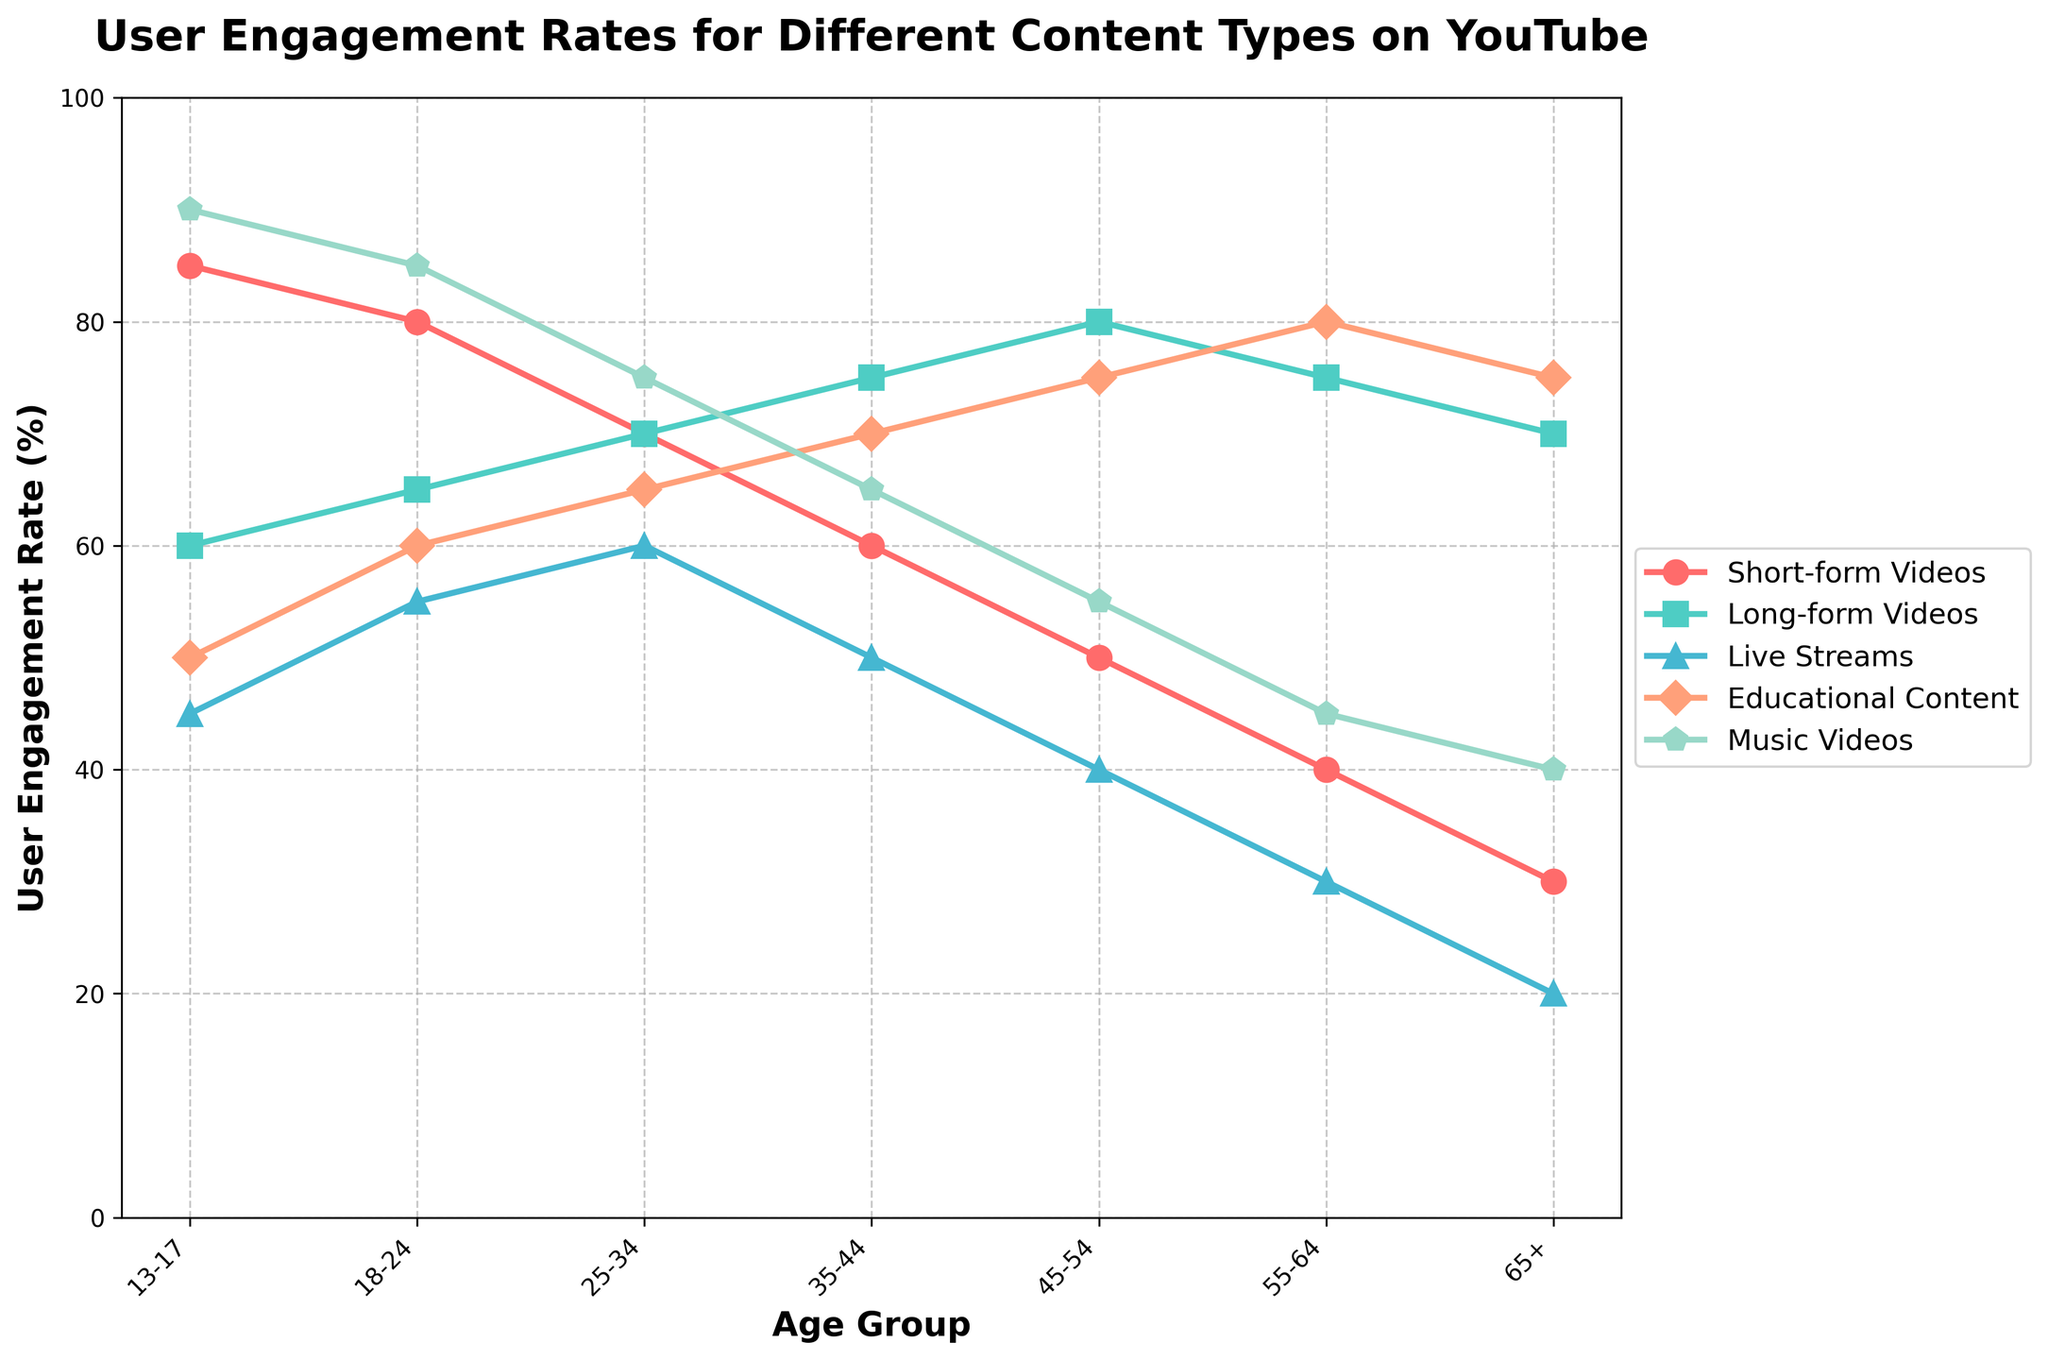Which age group has the highest engagement rate for short-form videos? Looking at the plot, the highest line for short-form videos is at the leftmost part of the chart. The age group 13-17 shows the highest point in the short-form videos line.
Answer: 13-17 Which content type shows a consistent increase in engagement rate as the age group increases from 13-17 to 55-64? Reviewing all the lines, Educational Content shows a consistent increase from age group 13-17 to age group 55-64.
Answer: Educational Content What's the difference in engagement rates between music videos and live streams for the 25-34 age group? Finding the respective points for the 25-34 age group, music videos are at 75, and live streams are at 60. The difference is 75 - 60.
Answer: 15 Among all the content types, which has the lowest engagement rate for the 65+ age group? Finding the points corresponding to the 65+ age group on the plot for each content type, Live Streams shows the lowest engagement rate at 20.
Answer: Live Streams What is the average engagement rate for long-form videos across all age groups? Identifying the values for long-form videos (60, 65, 70, 75, 80, 75, 70) and calculating their average: (60 + 65 + 70 + 75 + 80 + 75 + 70) / 7 = 70.71
Answer: 70.71 How does the engagement rate for short-form videos compare to educational content for the 18-24 age group? Checking the values for the 18-24 age group, short-form videos have an engagement rate of 80, and educational content has a rate of 60. Short-form videos have a higher engagement rate.
Answer: Short-form videos have a higher engagement rate What's the sum of engagement rates for educational content across the 35-44 and 45-54 age groups? Finding educational content rates for the respective age groups, they are 70 and 75. Summing them gives 70 + 75 = 145.
Answer: 145 Which age group has an equal engagement rate for both short-form videos and long-form videos? The age group where both short-form videos and long-form videos lines intersect is at 25-34, where both are at 70.
Answer: 25-34 What color represents live streams in the line chart? By observing the color legend, live streams are represented by the color green.
Answer: Green 